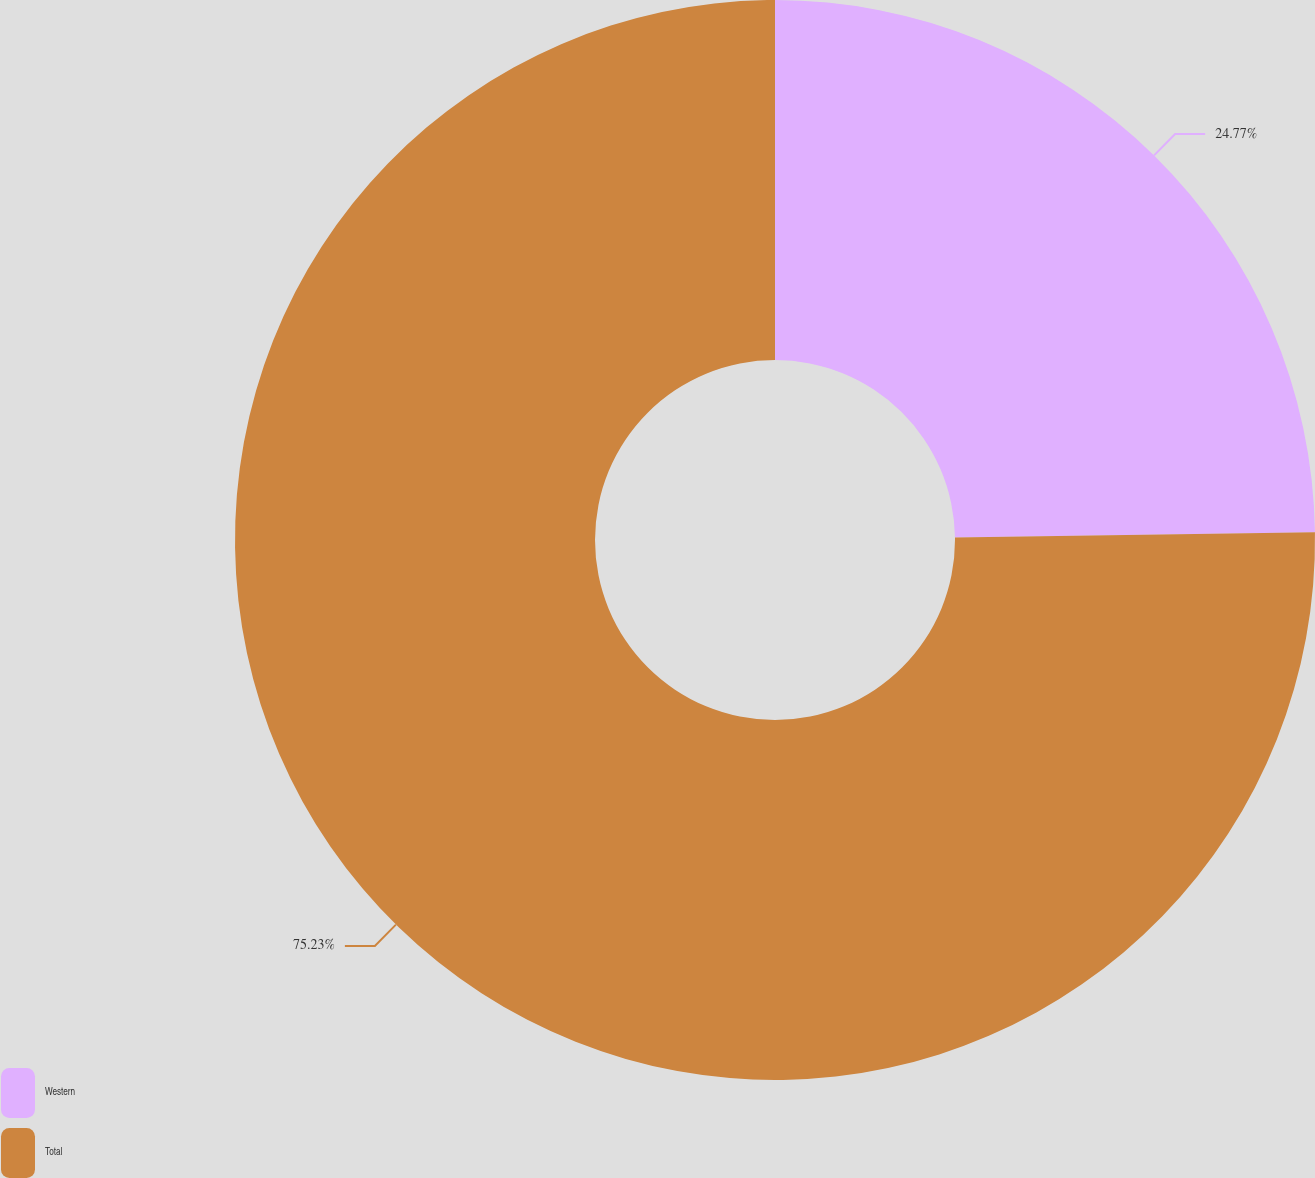Convert chart. <chart><loc_0><loc_0><loc_500><loc_500><pie_chart><fcel>Western<fcel>Total<nl><fcel>24.77%<fcel>75.23%<nl></chart> 